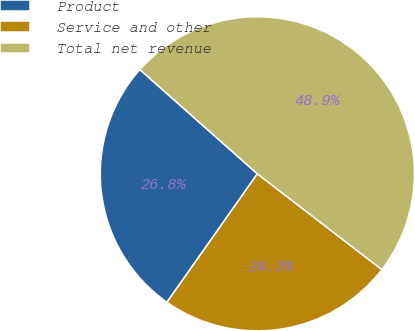Convert chart to OTSL. <chart><loc_0><loc_0><loc_500><loc_500><pie_chart><fcel>Product<fcel>Service and other<fcel>Total net revenue<nl><fcel>26.79%<fcel>24.33%<fcel>48.88%<nl></chart> 